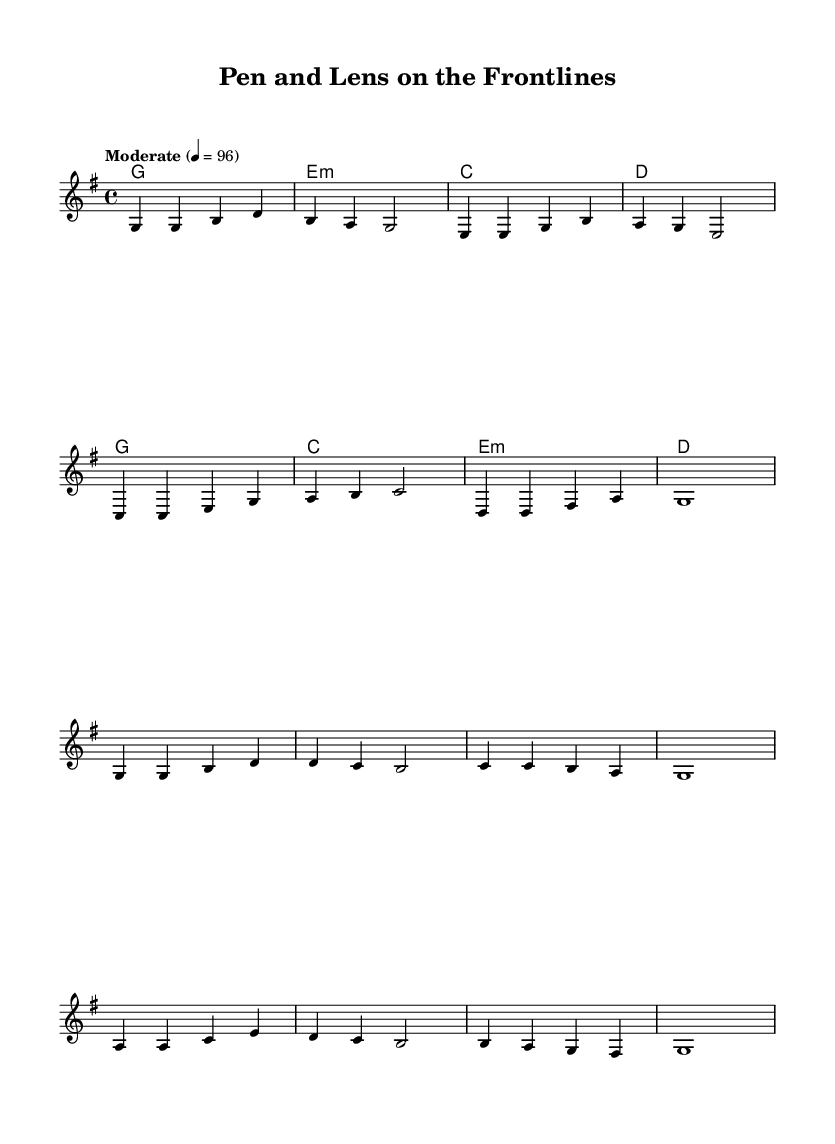What is the key signature of this music? The key signature is indicated at the beginning of the score, which shows one sharp (F#) in the key of G major.
Answer: G major What is the time signature of this sheet music? The time signature is located at the beginning of the score, displaying a 4 over 4. This indicates that there are four beats in each measure and a quarter note receives one beat.
Answer: 4/4 What is the tempo marking for this piece? The tempo marking appears at the beginning of the score, showing "Moderate." This specifies the desired speed of the piece, which is set at 96 beats per minute.
Answer: Moderate How many measures are in the verse? To determine the number of measures in the verse, we count the separate groupings of notes and rests, which totals eight distinct measures.
Answer: 8 What major themes are explored in the lyrics of this song? The lyrics illustrate themes of journalism, truth, and the challenges faced in conflict zones. This is contained within the verses that emphasize a journalist’s role in chaotic environments.
Answer: Journalism, truth, conflict What is the style of the harmonies in the verse? The harmonies in the verse consist of simple triads that accompany the melody and support the lyrics, typical of Americana-style country music. They follow a predictable progression.
Answer: Triads What do the lyrics convey about the role of journalists in conflict? The lyrics express a commitment to revealing the truth and documenting events, underscoring the bravery and dedication of journalists in dangerous situations.
Answer: Commitment, bravery 